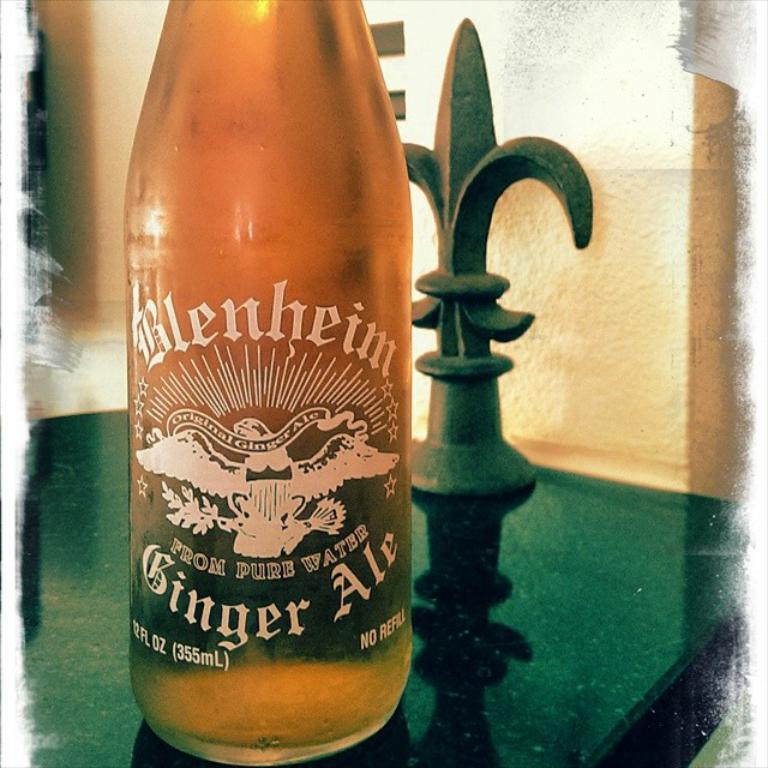<image>
Provide a brief description of the given image. A bottle of Blenheim Ginger Ale is sitting on a table. 